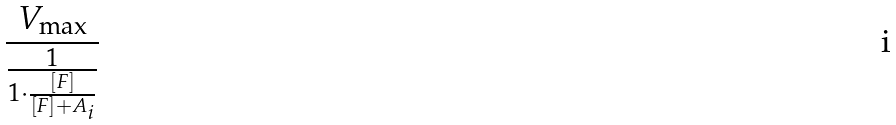<formula> <loc_0><loc_0><loc_500><loc_500>\frac { V _ { \max } } { \frac { 1 } { 1 \cdot \frac { [ F ] } { [ F ] + A _ { i } } } }</formula> 